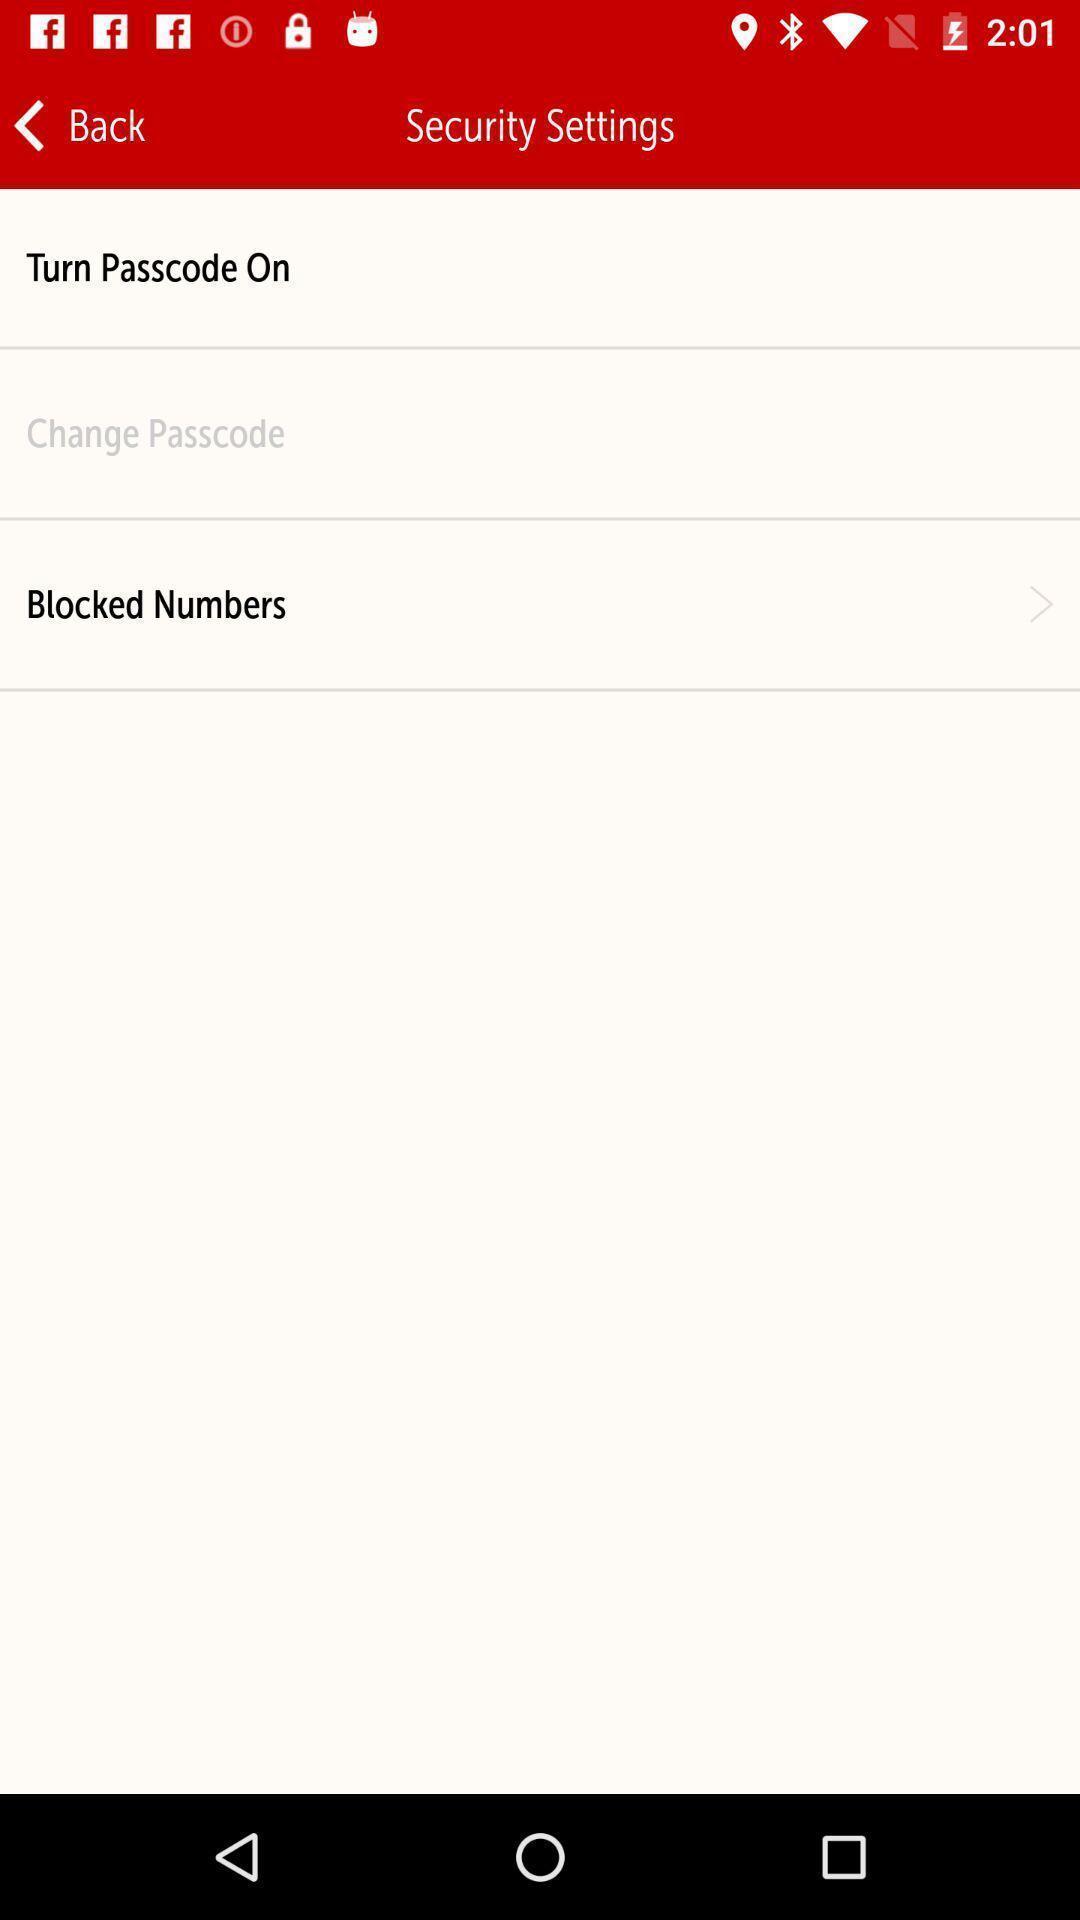Give me a summary of this screen capture. Window displaying the security settings page. 